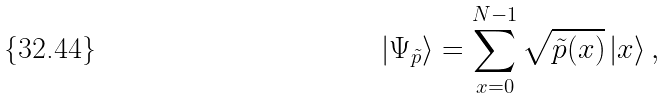Convert formula to latex. <formula><loc_0><loc_0><loc_500><loc_500>| \Psi _ { \tilde { p } } \rangle = \sum _ { x = 0 } ^ { N - 1 } \sqrt { \tilde { p } ( x ) } \, | x \rangle \, ,</formula> 